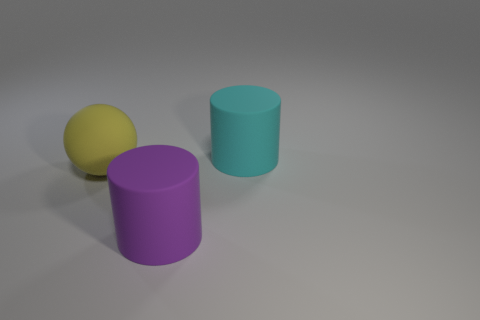Add 1 shiny blocks. How many objects exist? 4 Subtract all cylinders. How many objects are left? 1 Subtract 0 red spheres. How many objects are left? 3 Subtract all tiny blue cylinders. Subtract all cyan cylinders. How many objects are left? 2 Add 3 large yellow matte things. How many large yellow matte things are left? 4 Add 3 small brown shiny balls. How many small brown shiny balls exist? 3 